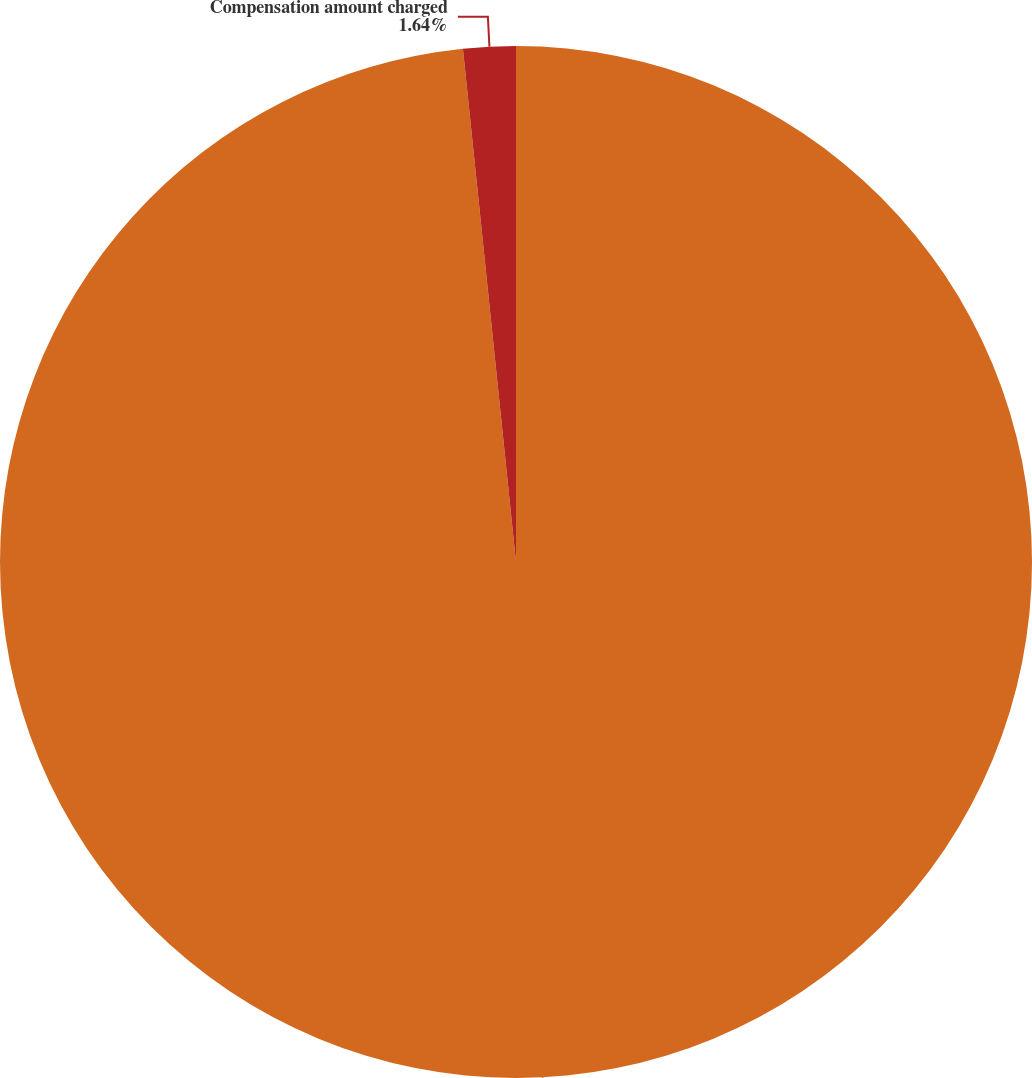Convert chart. <chart><loc_0><loc_0><loc_500><loc_500><pie_chart><fcel>For the years ended December<fcel>Compensation amount charged<nl><fcel>98.36%<fcel>1.64%<nl></chart> 